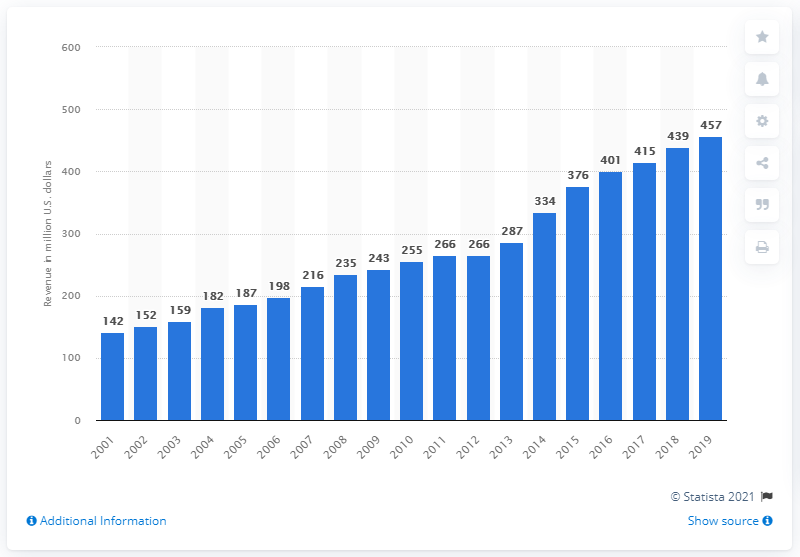Give some essential details in this illustration. In the year 2001, the Pittsburgh Steelers first made money. The revenue of the Pittsburgh Steelers in 2019 was $457 million. 